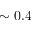<formula> <loc_0><loc_0><loc_500><loc_500>\sim 0 . 4</formula> 